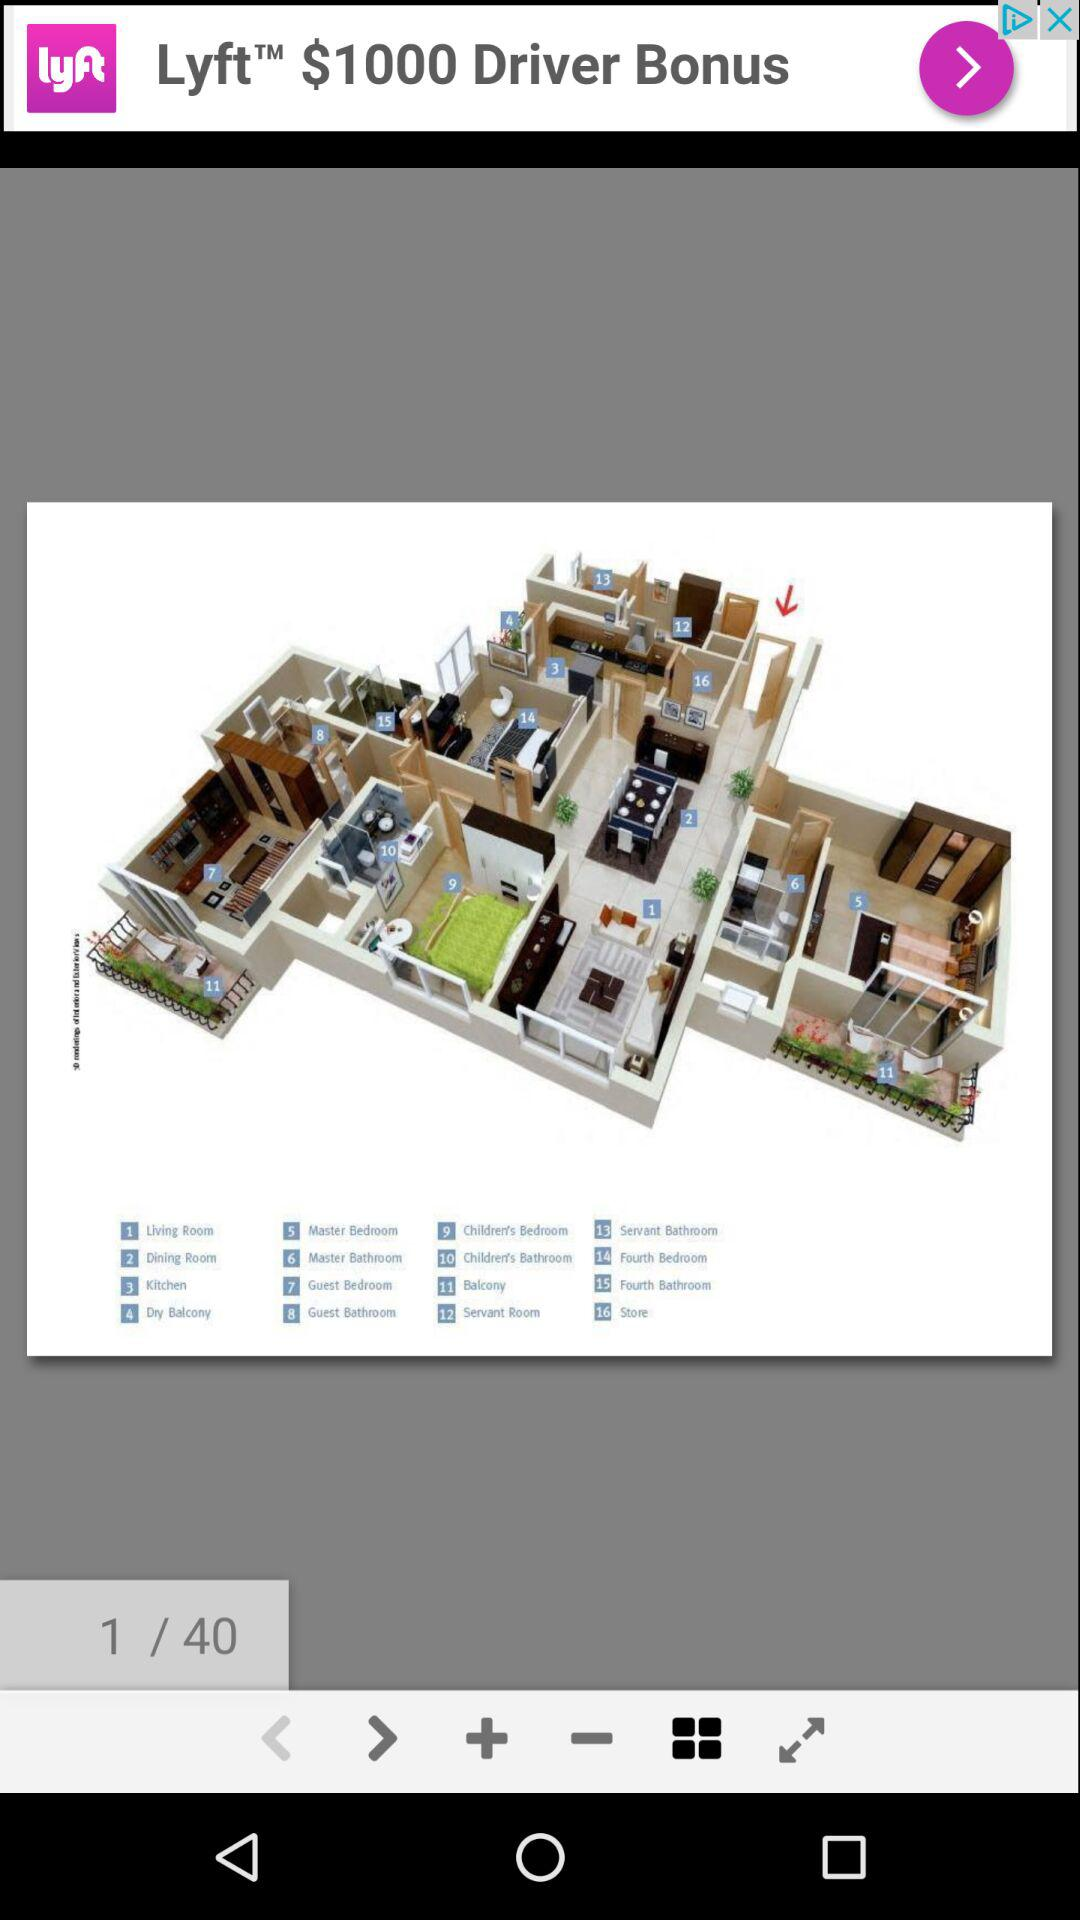Which image is shown now? It is the first image that is shown now. 